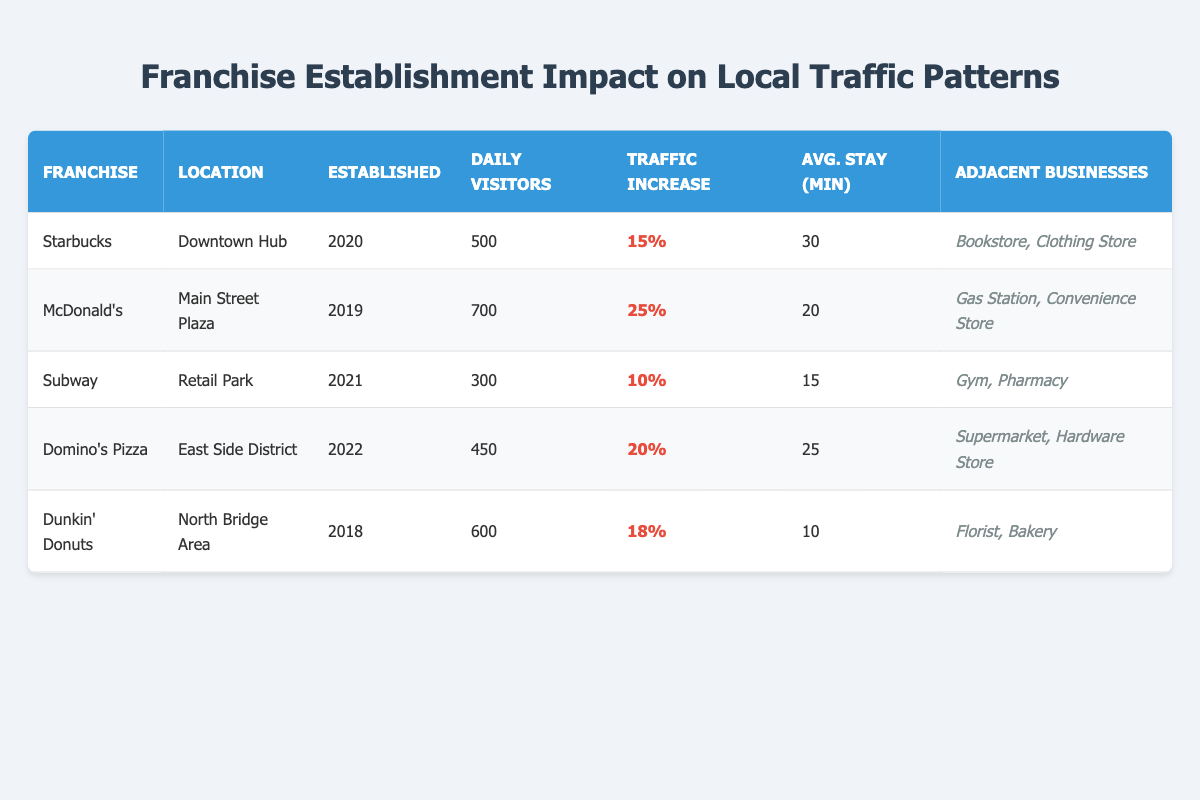What is the daily visitor count for McDonald's? From the table, I can see the row for McDonald's, which lists the daily visitors directly as 700.
Answer: 700 Which franchise has the highest traffic increase percentage? By examining the traffic increase percentages in each row, I identify that McDonald's has the highest percentage, which is 25%.
Answer: 25% How many adjacent businesses are listed for Domino's Pizza? The adjacent businesses for Domino's Pizza are listed in the same row as "Supermarket, Hardware Store". Counting those gives a total of 2 adjacent businesses.
Answer: 2 What is the average daily visitor count for all franchises? To find the average, I sum the daily visitors for all franchises: (500 + 700 + 300 + 450 + 600) = 2550. Since there are 5 franchises, I divide the total by 5, which gives 2550/5 = 510.
Answer: 510 Is the average customer stay for Subway longer than for Dunkin' Donuts? From the table, I can see that Subway has an average customer stay of 15 minutes while Dunkin' Donuts has an average stay of 10 minutes. Since 15 is greater than 10, the statement is true.
Answer: Yes Which franchise has the lowest daily visitor count and what is that count? Checking the daily visitor counts for all franchises, Subway has the lowest count at 300.
Answer: 300 What is the total traffic increase percentage when combining Starbucks and Domino's Pizza? By adding the traffic increase percentages for Starbucks (15%) and Domino's Pizza (20%), I calculate 15 + 20 = 35%.
Answer: 35% Did any of the franchises established after 2020 have more than 400 daily visitors? Analyzing the franchise establishment years, both Subway (2021) and Domino's Pizza (2022) are established after 2020. Subway has 300 daily visitors, while Domino's has 450 daily visitors. Since 450 is greater than 400, the answer is yes.
Answer: Yes What is the average customer stay for all franchises combined? By observing the customer stay times, I sum them: (30 + 20 + 15 + 25 + 10) = 100. Dividing by the number of franchises (5) gives 100/5 = 20 minutes.
Answer: 20 